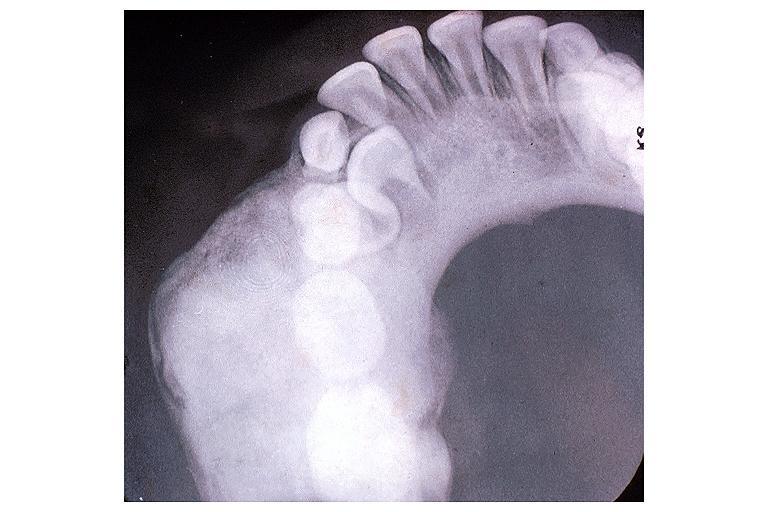where is this?
Answer the question using a single word or phrase. Oral 